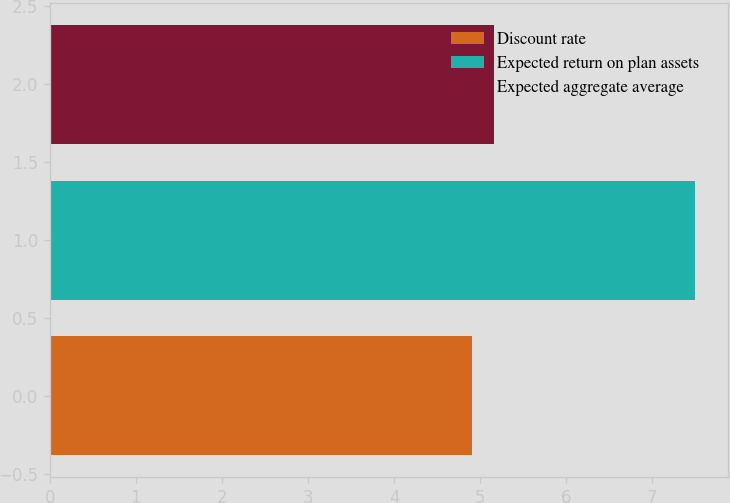<chart> <loc_0><loc_0><loc_500><loc_500><bar_chart><fcel>Discount rate<fcel>Expected return on plan assets<fcel>Expected aggregate average<nl><fcel>4.9<fcel>7.5<fcel>5.16<nl></chart> 